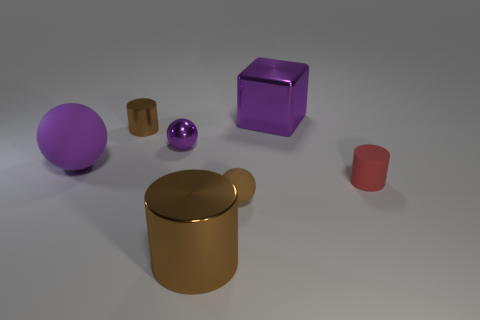Add 2 brown cylinders. How many objects exist? 9 Subtract all spheres. How many objects are left? 4 Subtract all tiny brown shiny cylinders. Subtract all purple shiny things. How many objects are left? 4 Add 3 metal balls. How many metal balls are left? 4 Add 5 tiny red objects. How many tiny red objects exist? 6 Subtract 0 gray cylinders. How many objects are left? 7 